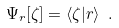<formula> <loc_0><loc_0><loc_500><loc_500>\Psi _ { r } [ \zeta ] = \langle \zeta | r \rangle \ .</formula> 